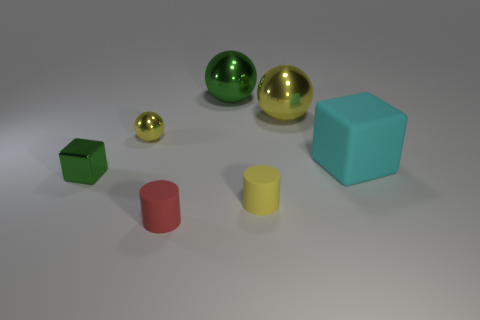Add 3 tiny yellow spheres. How many objects exist? 10 Subtract all cylinders. How many objects are left? 5 Add 3 small yellow rubber cylinders. How many small yellow rubber cylinders exist? 4 Subtract 0 cyan spheres. How many objects are left? 7 Subtract all matte blocks. Subtract all large green metallic spheres. How many objects are left? 5 Add 3 cyan matte objects. How many cyan matte objects are left? 4 